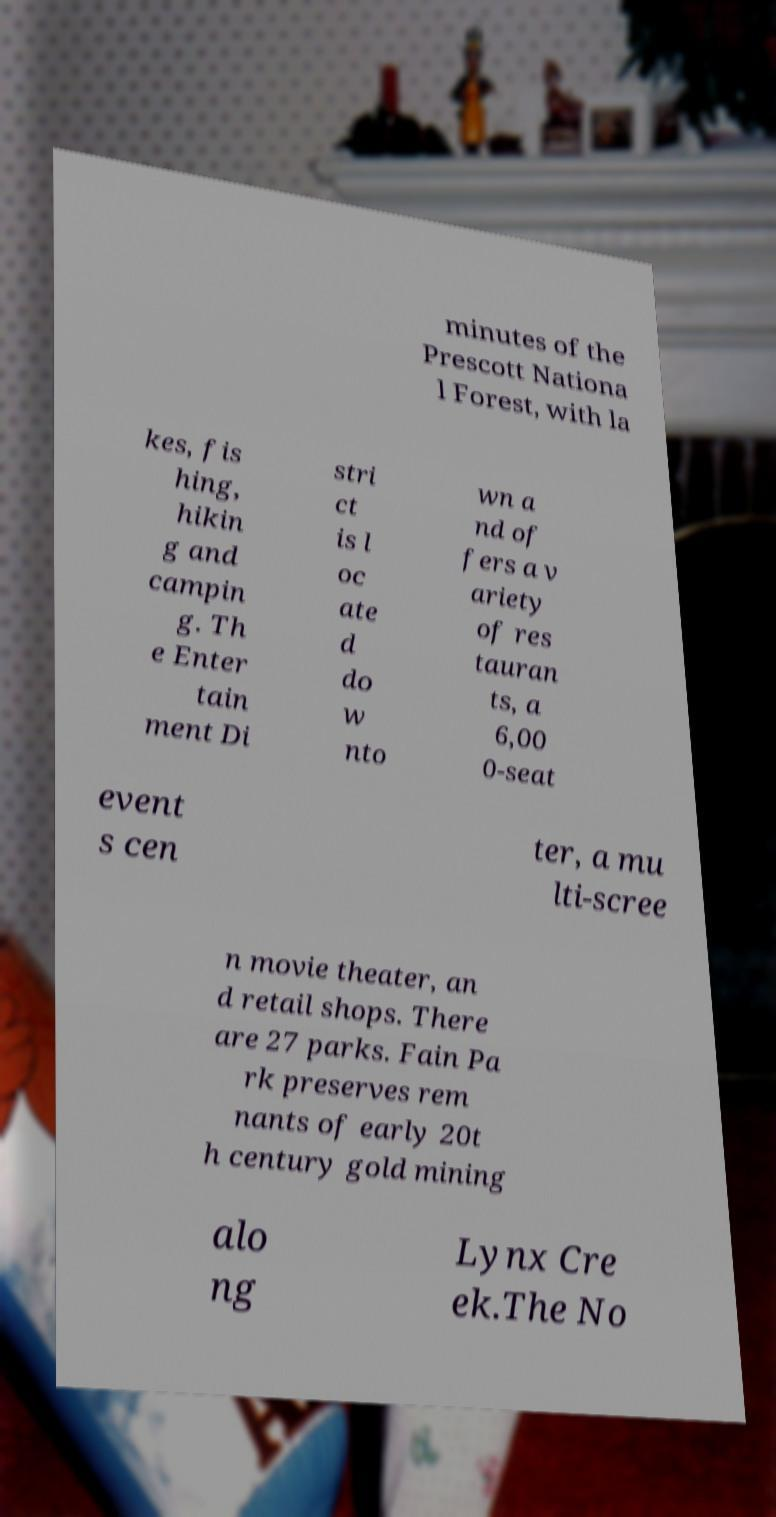I need the written content from this picture converted into text. Can you do that? minutes of the Prescott Nationa l Forest, with la kes, fis hing, hikin g and campin g. Th e Enter tain ment Di stri ct is l oc ate d do w nto wn a nd of fers a v ariety of res tauran ts, a 6,00 0-seat event s cen ter, a mu lti-scree n movie theater, an d retail shops. There are 27 parks. Fain Pa rk preserves rem nants of early 20t h century gold mining alo ng Lynx Cre ek.The No 